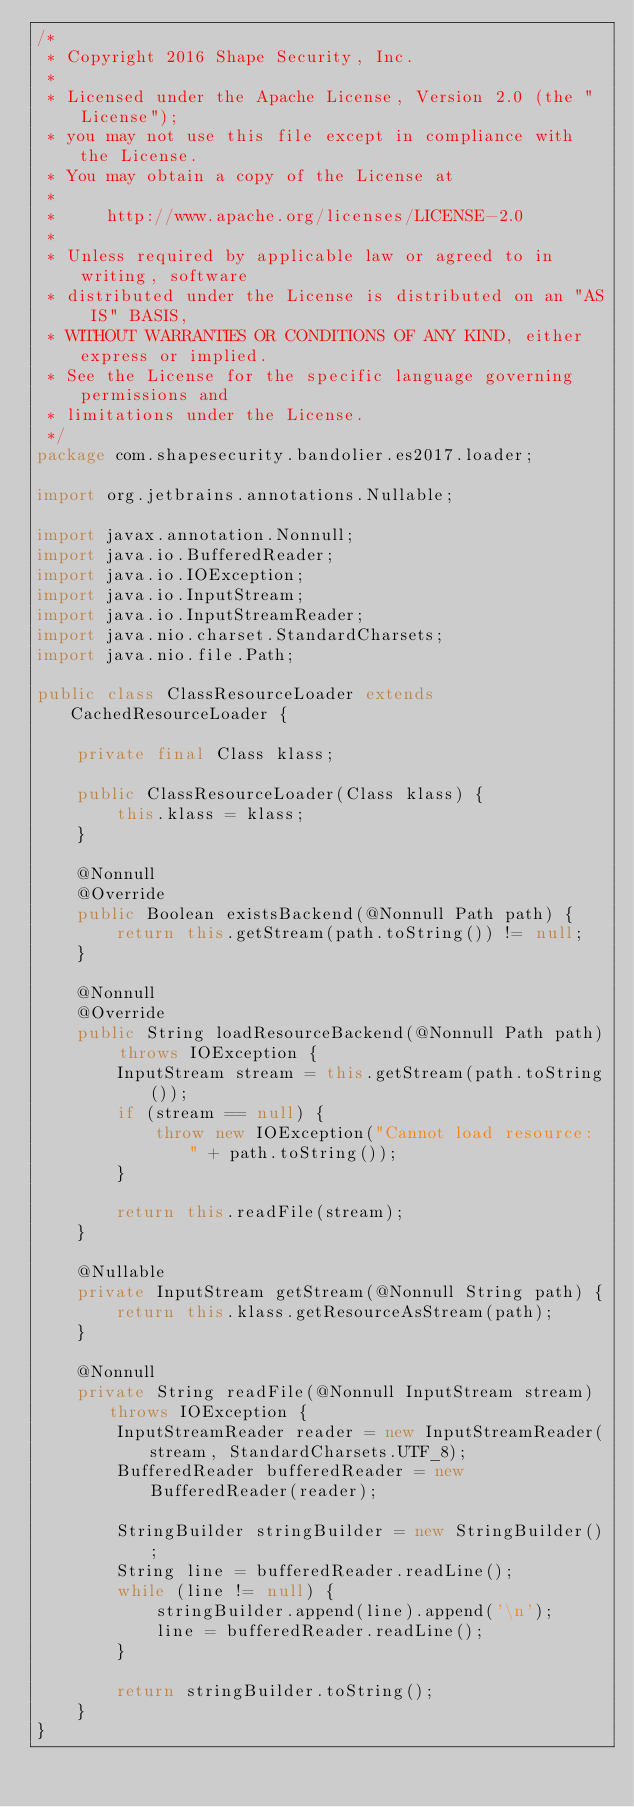<code> <loc_0><loc_0><loc_500><loc_500><_Java_>/*
 * Copyright 2016 Shape Security, Inc.
 *
 * Licensed under the Apache License, Version 2.0 (the "License");
 * you may not use this file except in compliance with the License.
 * You may obtain a copy of the License at
 *
 *     http://www.apache.org/licenses/LICENSE-2.0
 *
 * Unless required by applicable law or agreed to in writing, software
 * distributed under the License is distributed on an "AS IS" BASIS,
 * WITHOUT WARRANTIES OR CONDITIONS OF ANY KIND, either express or implied.
 * See the License for the specific language governing permissions and
 * limitations under the License.
 */
package com.shapesecurity.bandolier.es2017.loader;

import org.jetbrains.annotations.Nullable;

import javax.annotation.Nonnull;
import java.io.BufferedReader;
import java.io.IOException;
import java.io.InputStream;
import java.io.InputStreamReader;
import java.nio.charset.StandardCharsets;
import java.nio.file.Path;

public class ClassResourceLoader extends CachedResourceLoader {

	private final Class klass;

	public ClassResourceLoader(Class klass) {
		this.klass = klass;
	}

	@Nonnull
	@Override
	public Boolean existsBackend(@Nonnull Path path) {
		return this.getStream(path.toString()) != null;
	}

	@Nonnull
	@Override
	public String loadResourceBackend(@Nonnull Path path) throws IOException {
		InputStream stream = this.getStream(path.toString());
		if (stream == null) {
			throw new IOException("Cannot load resource: " + path.toString());
		}

		return this.readFile(stream);
	}

	@Nullable
	private InputStream getStream(@Nonnull String path) {
		return this.klass.getResourceAsStream(path);
	}

	@Nonnull
	private String readFile(@Nonnull InputStream stream) throws IOException {
		InputStreamReader reader = new InputStreamReader(stream, StandardCharsets.UTF_8);
		BufferedReader bufferedReader = new BufferedReader(reader);

		StringBuilder stringBuilder = new StringBuilder();
		String line = bufferedReader.readLine();
		while (line != null) {
			stringBuilder.append(line).append('\n');
			line = bufferedReader.readLine();
		}

		return stringBuilder.toString();
	}
}

</code> 